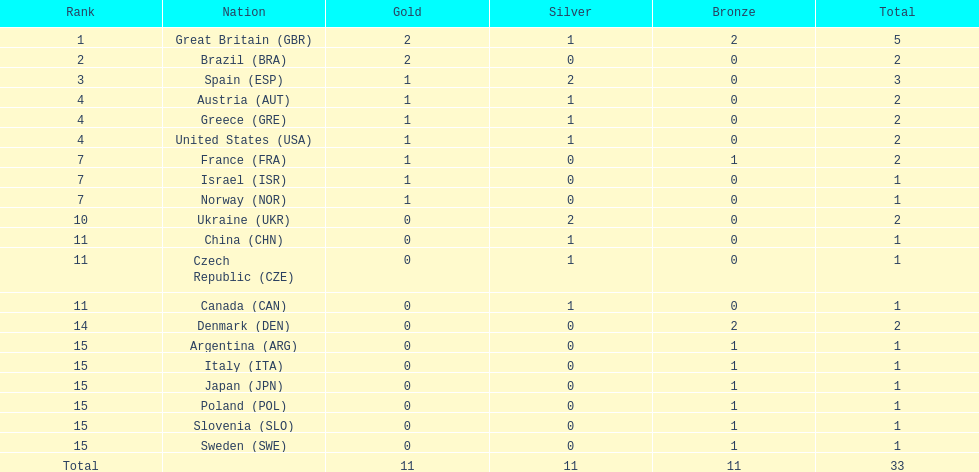Who obtained more gold medals than spain? Great Britain (GBR), Brazil (BRA). 